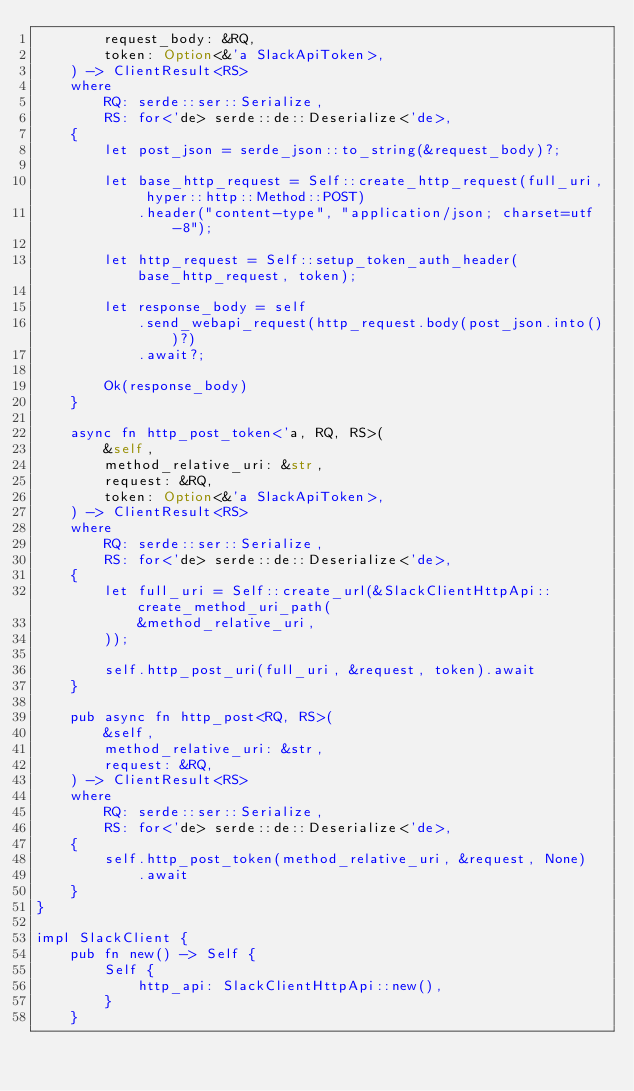Convert code to text. <code><loc_0><loc_0><loc_500><loc_500><_Rust_>        request_body: &RQ,
        token: Option<&'a SlackApiToken>,
    ) -> ClientResult<RS>
    where
        RQ: serde::ser::Serialize,
        RS: for<'de> serde::de::Deserialize<'de>,
    {
        let post_json = serde_json::to_string(&request_body)?;

        let base_http_request = Self::create_http_request(full_uri, hyper::http::Method::POST)
            .header("content-type", "application/json; charset=utf-8");

        let http_request = Self::setup_token_auth_header(base_http_request, token);

        let response_body = self
            .send_webapi_request(http_request.body(post_json.into())?)
            .await?;

        Ok(response_body)
    }

    async fn http_post_token<'a, RQ, RS>(
        &self,
        method_relative_uri: &str,
        request: &RQ,
        token: Option<&'a SlackApiToken>,
    ) -> ClientResult<RS>
    where
        RQ: serde::ser::Serialize,
        RS: for<'de> serde::de::Deserialize<'de>,
    {
        let full_uri = Self::create_url(&SlackClientHttpApi::create_method_uri_path(
            &method_relative_uri,
        ));

        self.http_post_uri(full_uri, &request, token).await
    }

    pub async fn http_post<RQ, RS>(
        &self,
        method_relative_uri: &str,
        request: &RQ,
    ) -> ClientResult<RS>
    where
        RQ: serde::ser::Serialize,
        RS: for<'de> serde::de::Deserialize<'de>,
    {
        self.http_post_token(method_relative_uri, &request, None)
            .await
    }
}

impl SlackClient {
    pub fn new() -> Self {
        Self {
            http_api: SlackClientHttpApi::new(),
        }
    }
</code> 